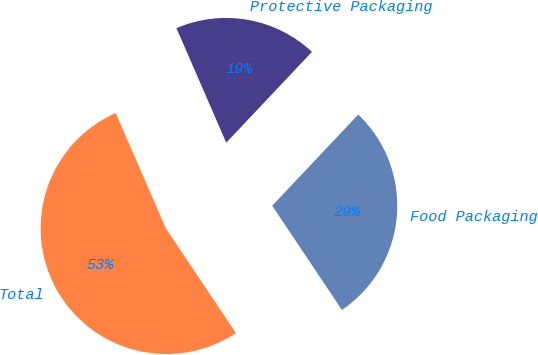Convert chart. <chart><loc_0><loc_0><loc_500><loc_500><pie_chart><fcel>Food Packaging<fcel>Protective Packaging<fcel>Total<nl><fcel>28.57%<fcel>18.57%<fcel>52.86%<nl></chart> 